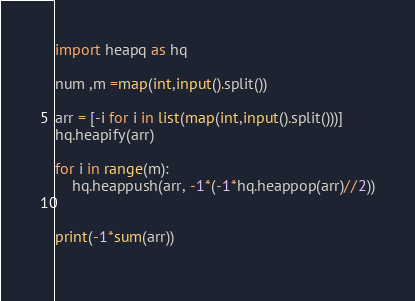<code> <loc_0><loc_0><loc_500><loc_500><_Python_>import heapq as hq

num ,m =map(int,input().split())

arr = [-i for i in list(map(int,input().split()))]
hq.heapify(arr)

for i in range(m):
    hq.heappush(arr, -1*(-1*hq.heappop(arr)//2))

    
print(-1*sum(arr))
       </code> 